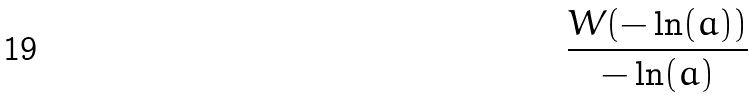<formula> <loc_0><loc_0><loc_500><loc_500>\frac { W ( - \ln ( a ) ) } { - \ln ( a ) }</formula> 